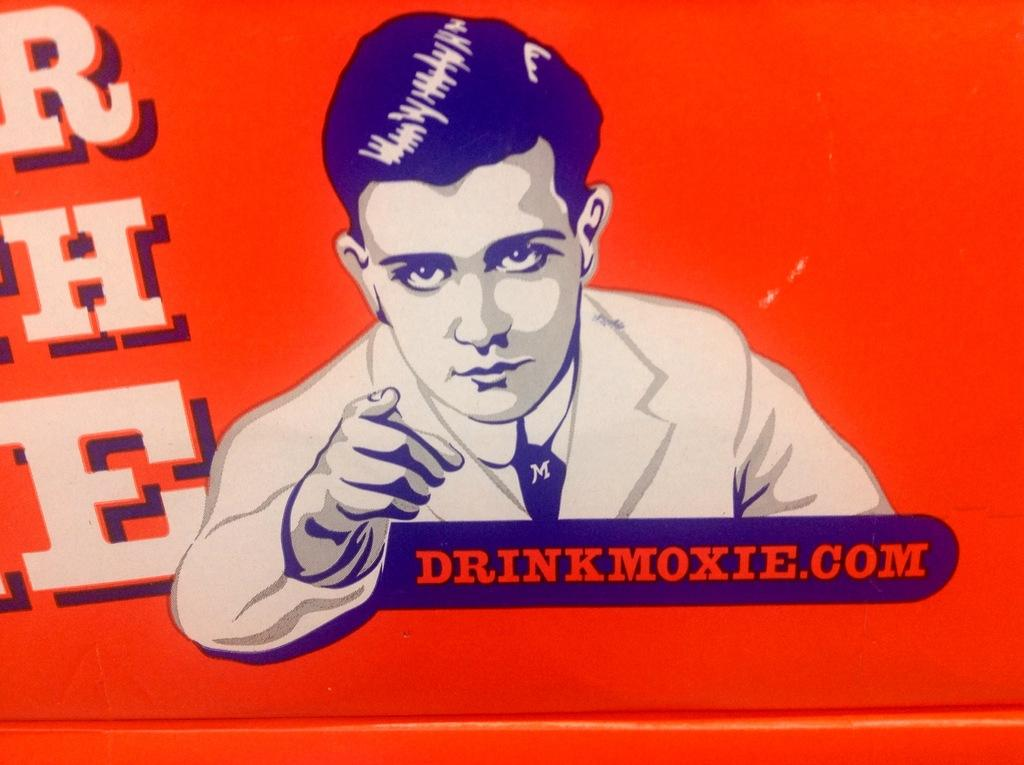What is depicted on the poster in the image? The poster contains a painting of a person. What else can be found on the poster besides the painting? There is writing on the poster. What type of soup is being served in the underwear on the poster? There is no soup or underwear present on the poster; it features a painting of a person and writing. 